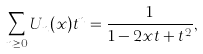Convert formula to latex. <formula><loc_0><loc_0><loc_500><loc_500>\sum _ { n \geq 0 } U _ { n } ( x ) t ^ { n } = \frac { 1 } { 1 - 2 x t + t ^ { 2 } } ,</formula> 